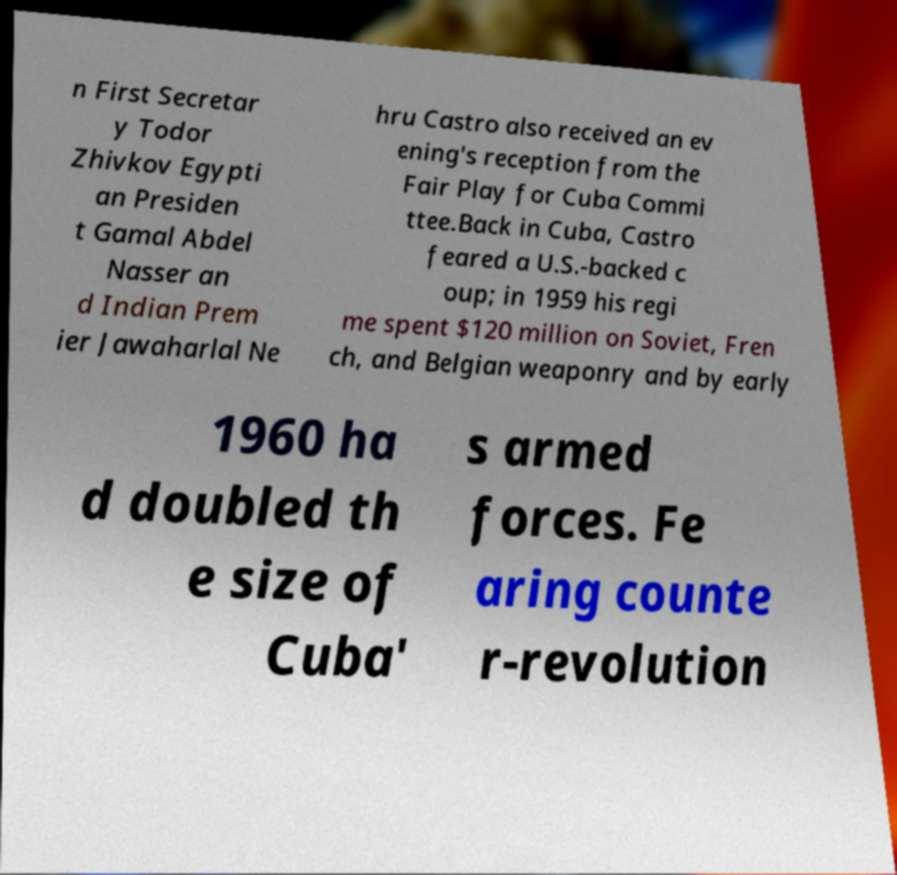Could you extract and type out the text from this image? n First Secretar y Todor Zhivkov Egypti an Presiden t Gamal Abdel Nasser an d Indian Prem ier Jawaharlal Ne hru Castro also received an ev ening's reception from the Fair Play for Cuba Commi ttee.Back in Cuba, Castro feared a U.S.-backed c oup; in 1959 his regi me spent $120 million on Soviet, Fren ch, and Belgian weaponry and by early 1960 ha d doubled th e size of Cuba' s armed forces. Fe aring counte r-revolution 